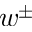Convert formula to latex. <formula><loc_0><loc_0><loc_500><loc_500>w ^ { \pm }</formula> 